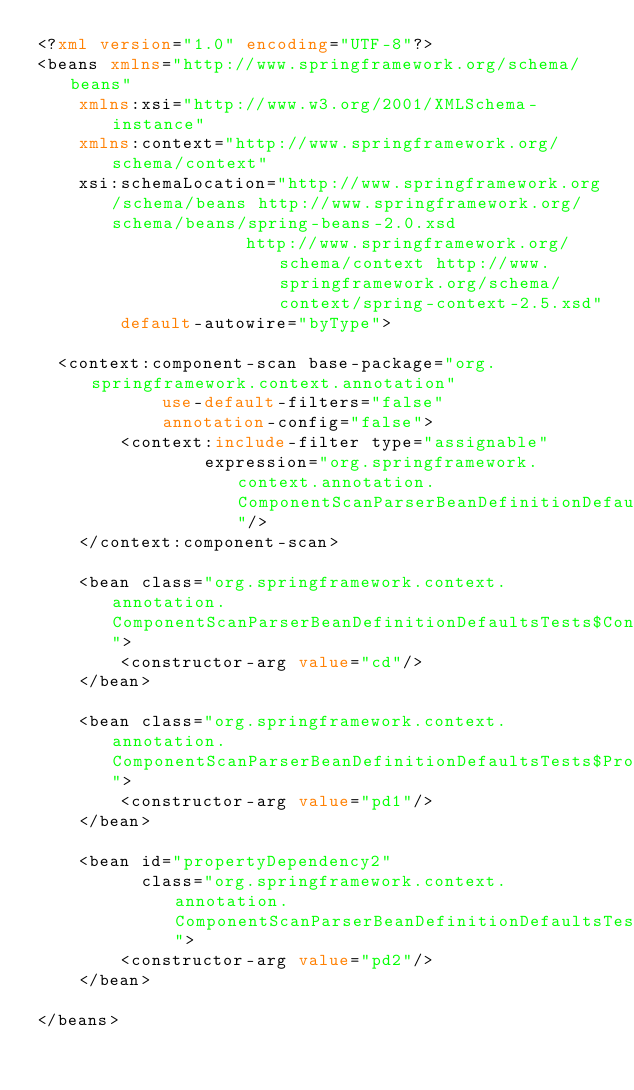Convert code to text. <code><loc_0><loc_0><loc_500><loc_500><_XML_><?xml version="1.0" encoding="UTF-8"?>
<beans xmlns="http://www.springframework.org/schema/beans"
		xmlns:xsi="http://www.w3.org/2001/XMLSchema-instance"
		xmlns:context="http://www.springframework.org/schema/context"
		xsi:schemaLocation="http://www.springframework.org/schema/beans http://www.springframework.org/schema/beans/spring-beans-2.0.xsd
				            http://www.springframework.org/schema/context http://www.springframework.org/schema/context/spring-context-2.5.xsd"
        default-autowire="byType">

	<context:component-scan base-package="org.springframework.context.annotation"
            use-default-filters="false"
            annotation-config="false">
        <context:include-filter type="assignable" 
                expression="org.springframework.context.annotation.ComponentScanParserBeanDefinitionDefaultsTests$DefaultsTestBean"/>
    </context:component-scan>

    <bean class="org.springframework.context.annotation.ComponentScanParserBeanDefinitionDefaultsTests$ConstructorDependencyTestBean">
        <constructor-arg value="cd"/>
    </bean>

    <bean class="org.springframework.context.annotation.ComponentScanParserBeanDefinitionDefaultsTests$PropertyDependencyTestBean">
        <constructor-arg value="pd1"/>
    </bean>

    <bean id="propertyDependency2" 
          class="org.springframework.context.annotation.ComponentScanParserBeanDefinitionDefaultsTests$PropertyDependencyTestBean">
        <constructor-arg value="pd2"/>
    </bean>

</beans>
</code> 